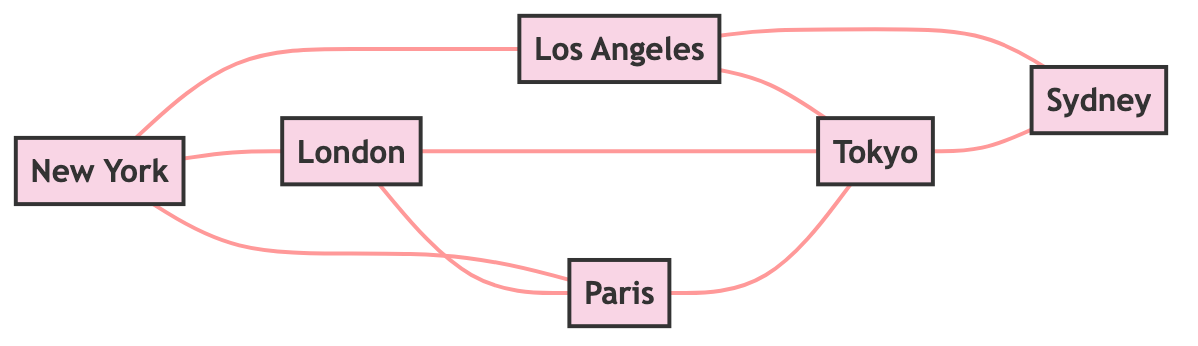What are the total number of cities represented in the graph? The graph has six nodes, each representing a city: New York, Los Angeles, London, Paris, Tokyo, and Sydney.
Answer: 6 How many direct flight routes are there from New York? New York has three direct connections: Los Angeles, London, and Paris. Therefore, it has three direct flight routes.
Answer: 3 Which cities have direct flight routes to both Tokyo and Sydney? Los Angeles and Tokyo are connected by a direct route, and Tokyo also has a direct flight route to Sydney. Therefore, the only cities with direct flight routes to both Tokyo and Sydney are Los Angeles and Tokyo.
Answer: Los Angeles Is there a direct flight route between Paris and Sydney? There is no edge connecting Paris to Sydney directly in the graph. Therefore, there is no direct flight route.
Answer: No How many cities are connected to Los Angeles? Los Angeles is directly connected to three cities: New York, Tokyo, and Sydney. Counting these, we find that it is connected to three cities.
Answer: 3 Which two cities have the most direct connections to other cities? New York has three connections and Los Angeles also has three connections, while the others have fewer. New York and Los Angeles are tied for the most connections.
Answer: New York and Los Angeles How many direct connections are there from London? London has two direct flight routes: one to Paris and the other to Tokyo. Thus, it has two direct connections.
Answer: 2 Can you name a city that is connected to both New York and Paris? The only city connected to both New York and Paris is London, as it has direct routes to both of these cities.
Answer: London Which city has the least number of direct flight routes? Cities like Sydney are only connected to Tokyo directly, indicating it has the least number of connections with just one direct flight.
Answer: Sydney 